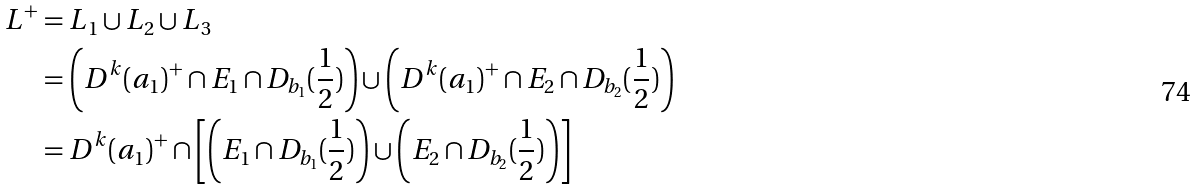Convert formula to latex. <formula><loc_0><loc_0><loc_500><loc_500>L ^ { + } & = L _ { 1 } \cup L _ { 2 } \cup L _ { 3 } \\ & = \left ( D ^ { k } ( a _ { 1 } ) ^ { + } \cap E _ { 1 } \cap D _ { b _ { 1 } } ( \frac { 1 } { 2 } ) \right ) \cup \left ( D ^ { k } ( a _ { 1 } ) ^ { + } \cap E _ { 2 } \cap D _ { b _ { 2 } } ( \frac { 1 } { 2 } ) \right ) \\ & = D ^ { k } ( a _ { 1 } ) ^ { + } \cap \left [ \left ( E _ { 1 } \cap D _ { b _ { 1 } } ( \frac { 1 } { 2 } ) \right ) \cup \left ( E _ { 2 } \cap D _ { b _ { 2 } } ( \frac { 1 } { 2 } ) \right ) \right ]</formula> 